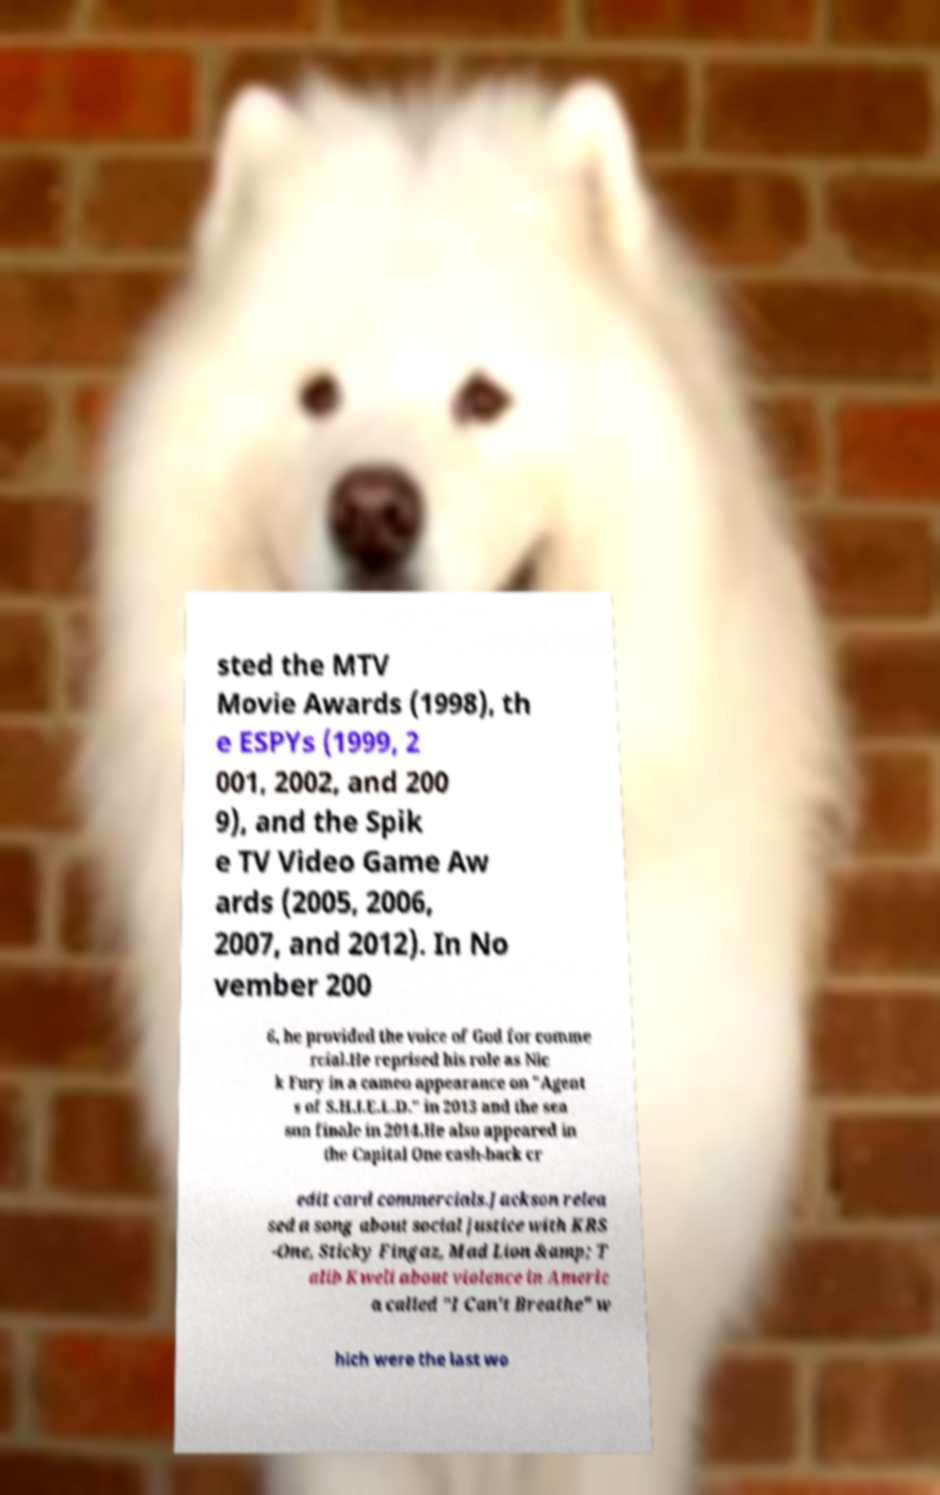For documentation purposes, I need the text within this image transcribed. Could you provide that? sted the MTV Movie Awards (1998), th e ESPYs (1999, 2 001, 2002, and 200 9), and the Spik e TV Video Game Aw ards (2005, 2006, 2007, and 2012). In No vember 200 6, he provided the voice of God for comme rcial.He reprised his role as Nic k Fury in a cameo appearance on "Agent s of S.H.I.E.L.D." in 2013 and the sea son finale in 2014.He also appeared in the Capital One cash-back cr edit card commercials.Jackson relea sed a song about social justice with KRS -One, Sticky Fingaz, Mad Lion &amp; T alib Kweli about violence in Americ a called "I Can't Breathe" w hich were the last wo 